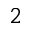<formula> <loc_0><loc_0><loc_500><loc_500>2</formula> 